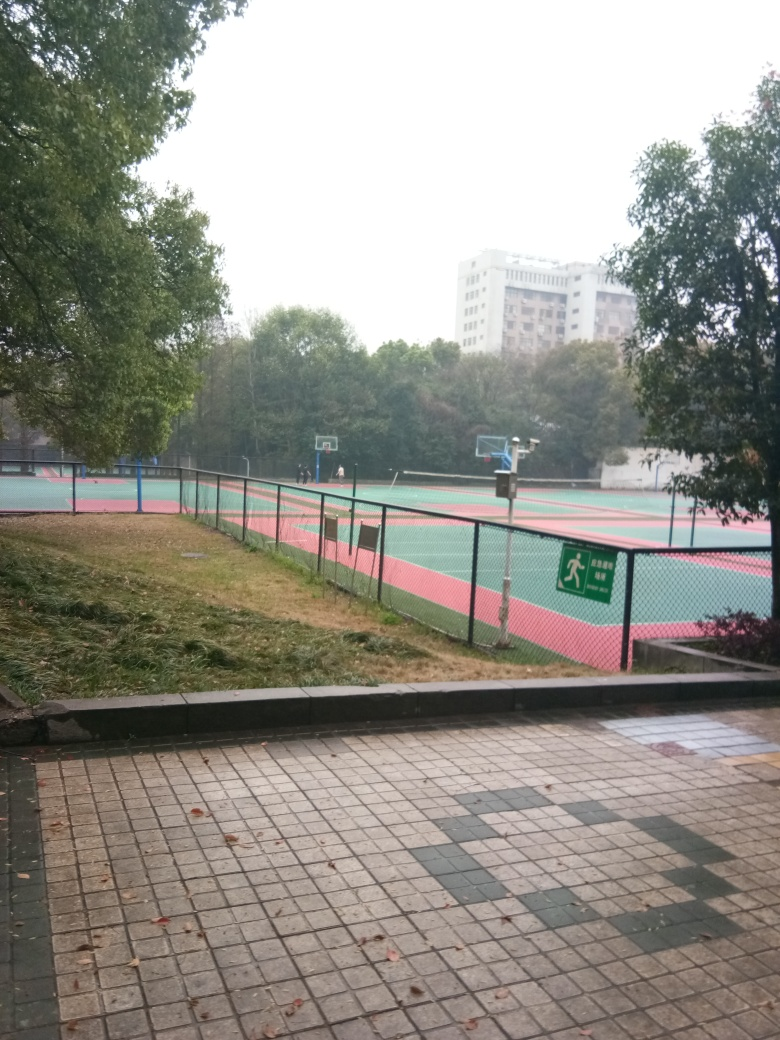Can you tell me what this place is used for? Based on the image, this appears to be an outdoor sports area, likely used for basketball, given the visible hoops and marked court. The flooring suggests it's also suitable for other sports such as tennis or volleyball. 